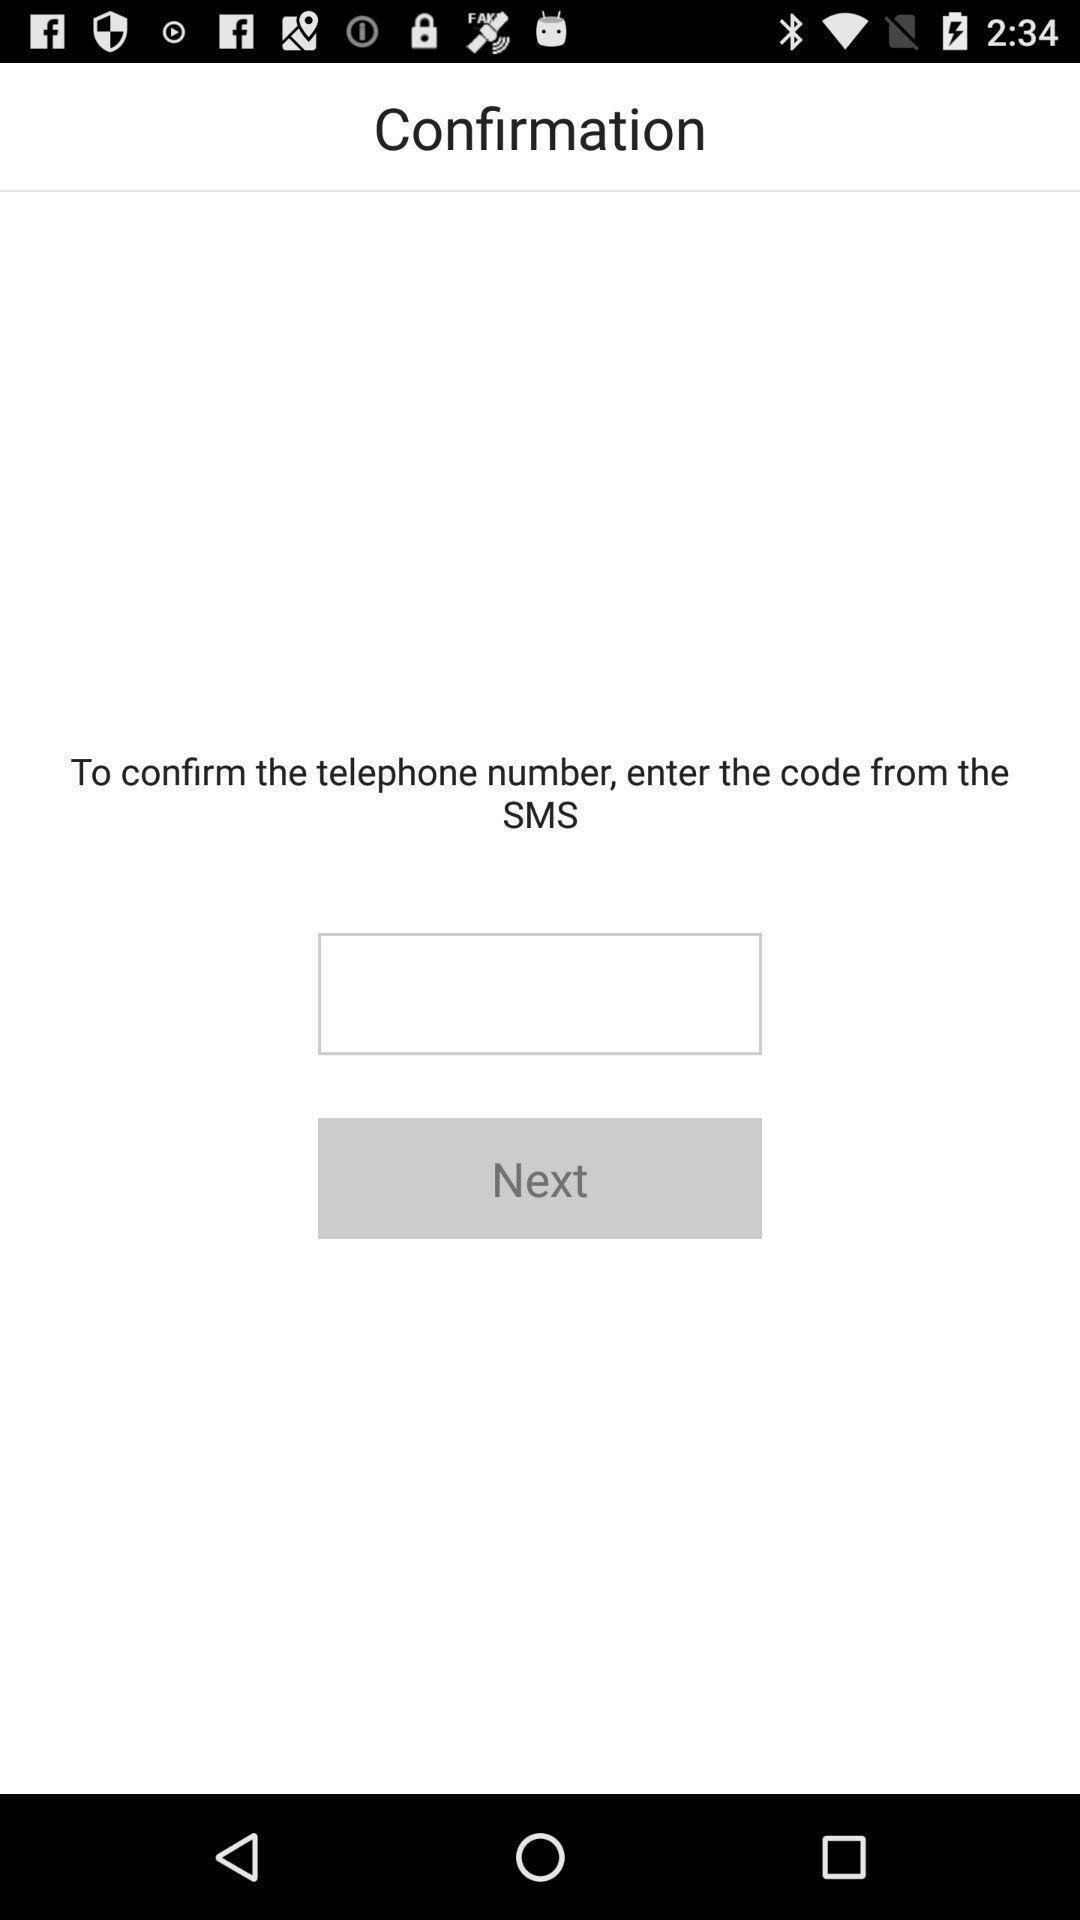Provide a detailed account of this screenshot. Page displaying to enter confirmation code to the app. 